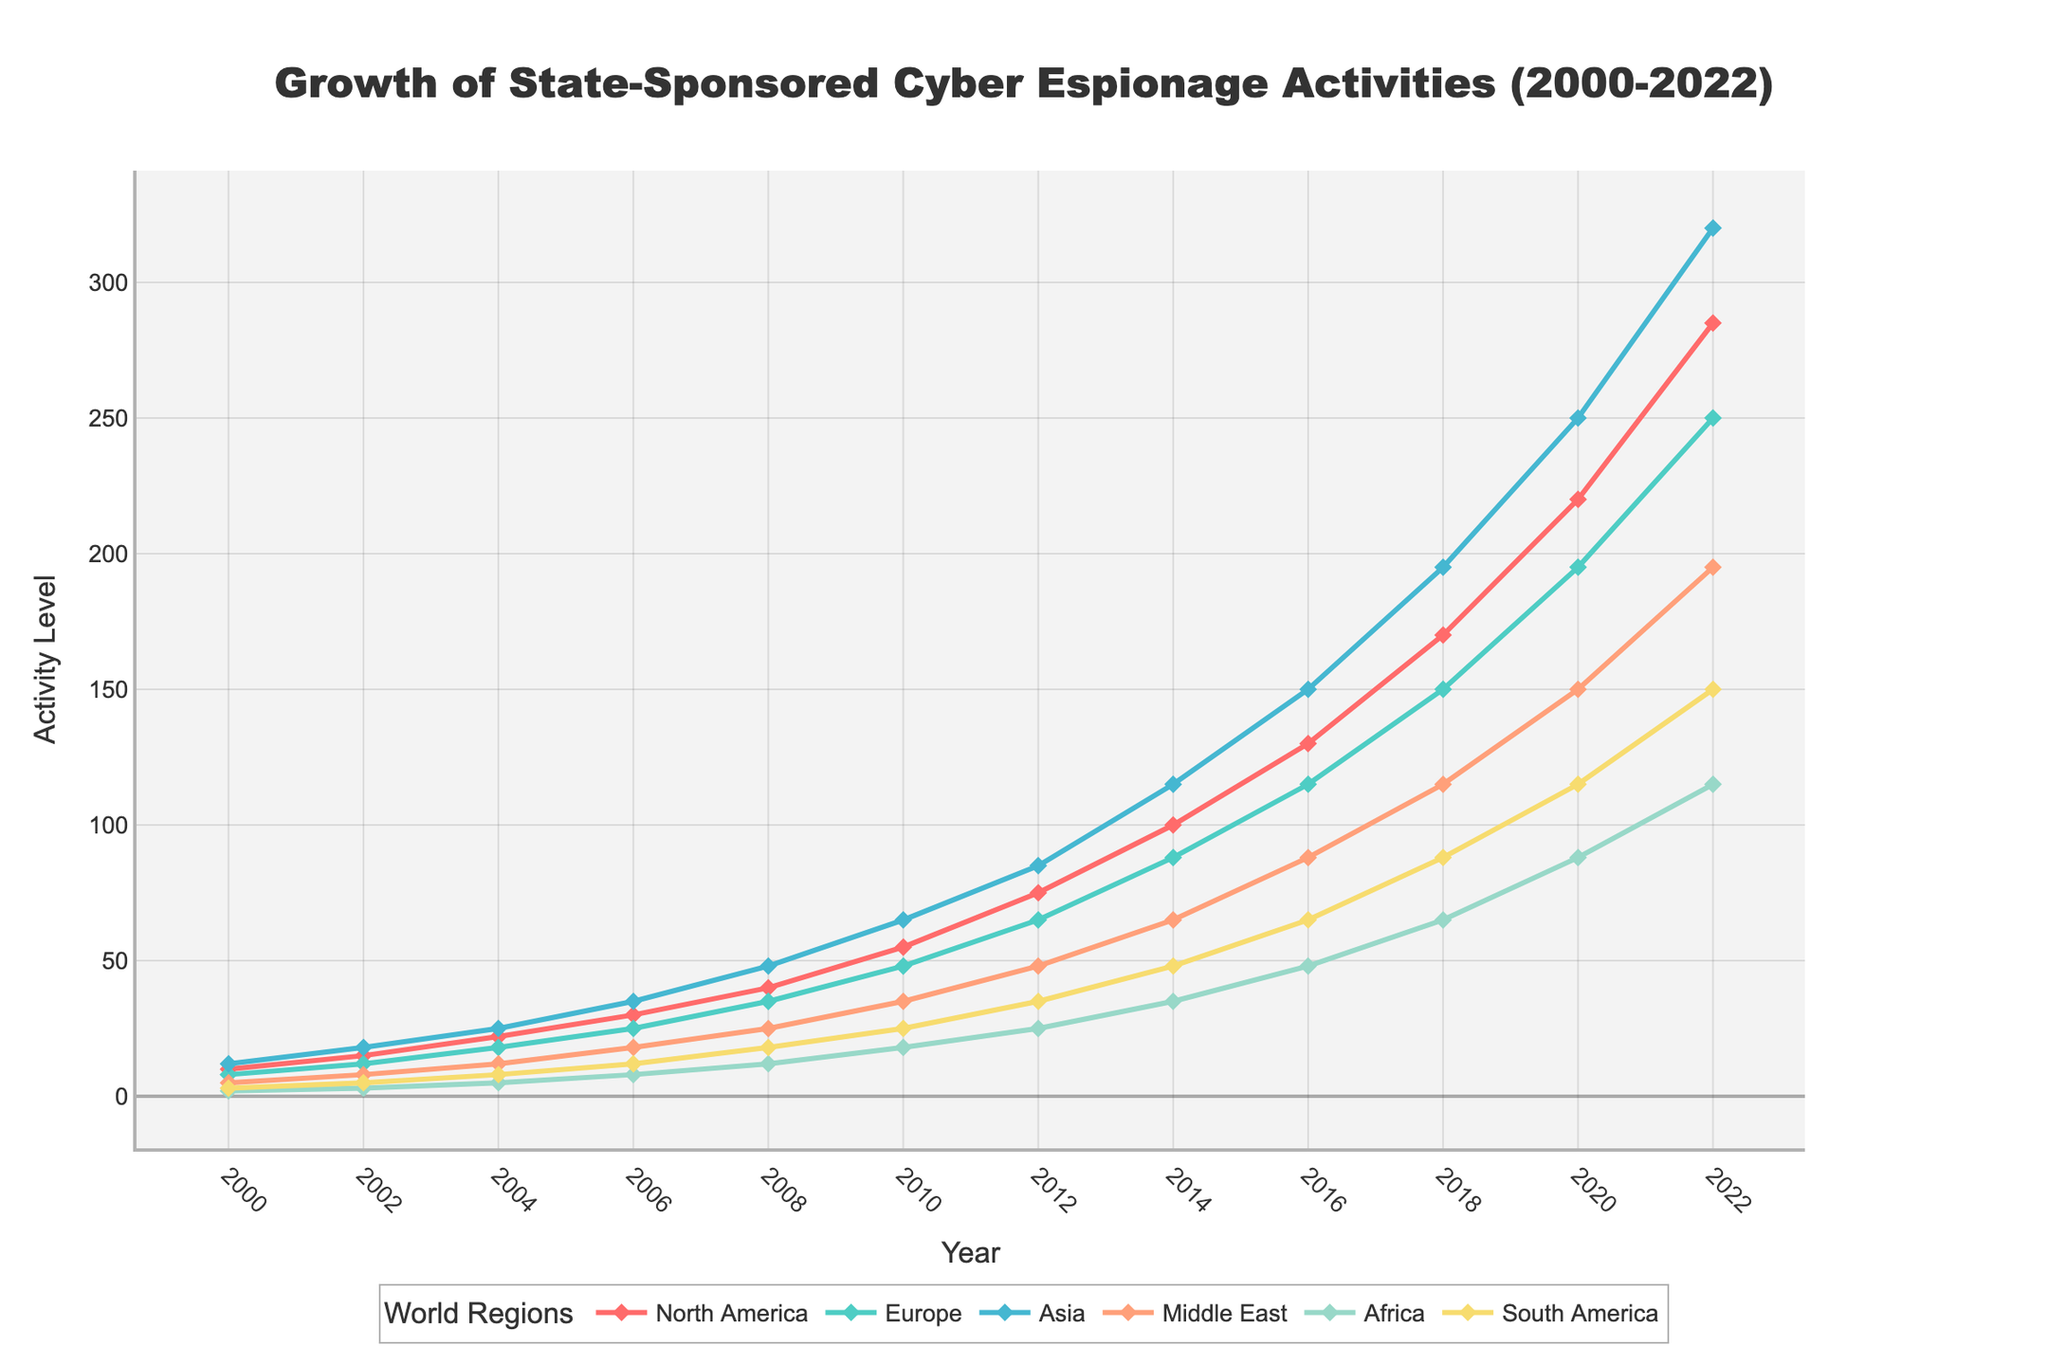What's the growth in cyber espionage activities in North America from 2000 to 2010? To find the growth in cyber espionage activities in North America from 2000 to 2010, subtract the activity level in 2000 from the activity level in 2010. The activity level in 2000 is 10, and in 2010 it is 55. Therefore, the growth is 55 - 10 = 45.
Answer: 45 Which region had the highest level of cyber espionage activities in 2022? To determine which region had the highest level in 2022, compare the values of all regions in that year. The activity levels in 2022 are: North America (285), Europe (250), Asia (320), Middle East (195), Africa (115), and South America (150). Asia has the highest value at 320.
Answer: Asia What is the average activity level in Europe between 2000 and 2010? To calculate the average activity level in Europe between 2000 and 2010, first identify the values for the years 2000, 2002, 2004, 2006, 2008, and 2010: 8, 12, 18, 25, 35, 48. Sum these values and divide by the number of years: (8 + 12 + 18 + 25 + 35 + 48) / 6 = 24.33 (rounded to 2 decimal places).
Answer: 24.33 Between 2008 and 2014, which region showed the most significant increase in cyber espionage activities? To identify the region with the most significant increase, calculate the difference in activity levels between 2008 and 2014 for each region: North America (100-40=60), Europe (88-35=53), Asia (115-48=67), Middle East (65-25=40), Africa (35-12=23), South America (48-18=30). Asia has the highest increase at 67.
Answer: Asia How does South America's activity level in 2020 compare to Asia's activity level in 2006? Compare the activity level in South America in 2020 (115) to Asia's level in 2006 (35). South America's level is greater than Asia's level.
Answer: Greater Which year did North America's cyber espionage activities surpass 50, and by how much did they exceed this threshold? The first year North America's activities surpassed 50 is 2010, with an activity level of 55. The amount by which they exceeded this threshold is 55 - 50 = 5.
Answer: 2010, 5 What is the difference between the highest and lowest activity levels in 2018 across all regions? Identify the highest and lowest activity levels in 2018: North America (170), Europe (150), Asia (195), Middle East (115), Africa (65), South America (88). The highest is 195 (Asia), and the lowest is 65 (Africa). The difference is 195 - 65 = 130.
Answer: 130 What was the rate of increase in cyber espionage activities in Asia from 2000 to 2004? To calculate the rate, subtract the activity level in 2000 from the level in 2004, then divide by the number of years. The values are 12 (2000) and 25 (2004): (25 - 12) / (2004 - 2000) = 13 / 4 = 3.25 per year.
Answer: 3.25 per year 